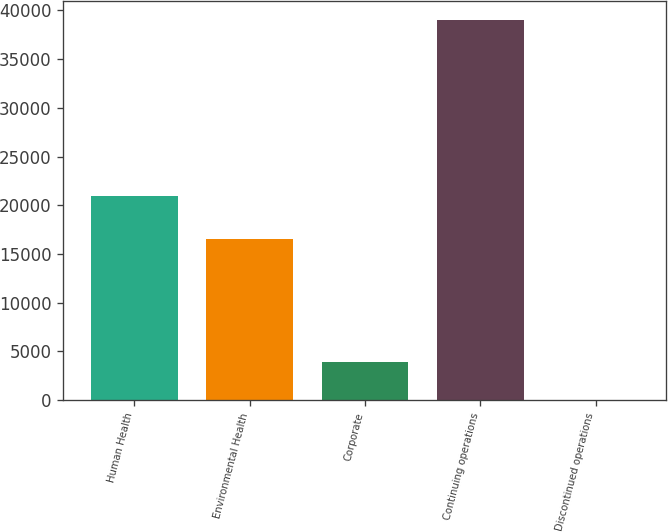Convert chart to OTSL. <chart><loc_0><loc_0><loc_500><loc_500><bar_chart><fcel>Human Health<fcel>Environmental Health<fcel>Corporate<fcel>Continuing operations<fcel>Discontinued operations<nl><fcel>20900<fcel>16532<fcel>3907.1<fcel>38981<fcel>10<nl></chart> 